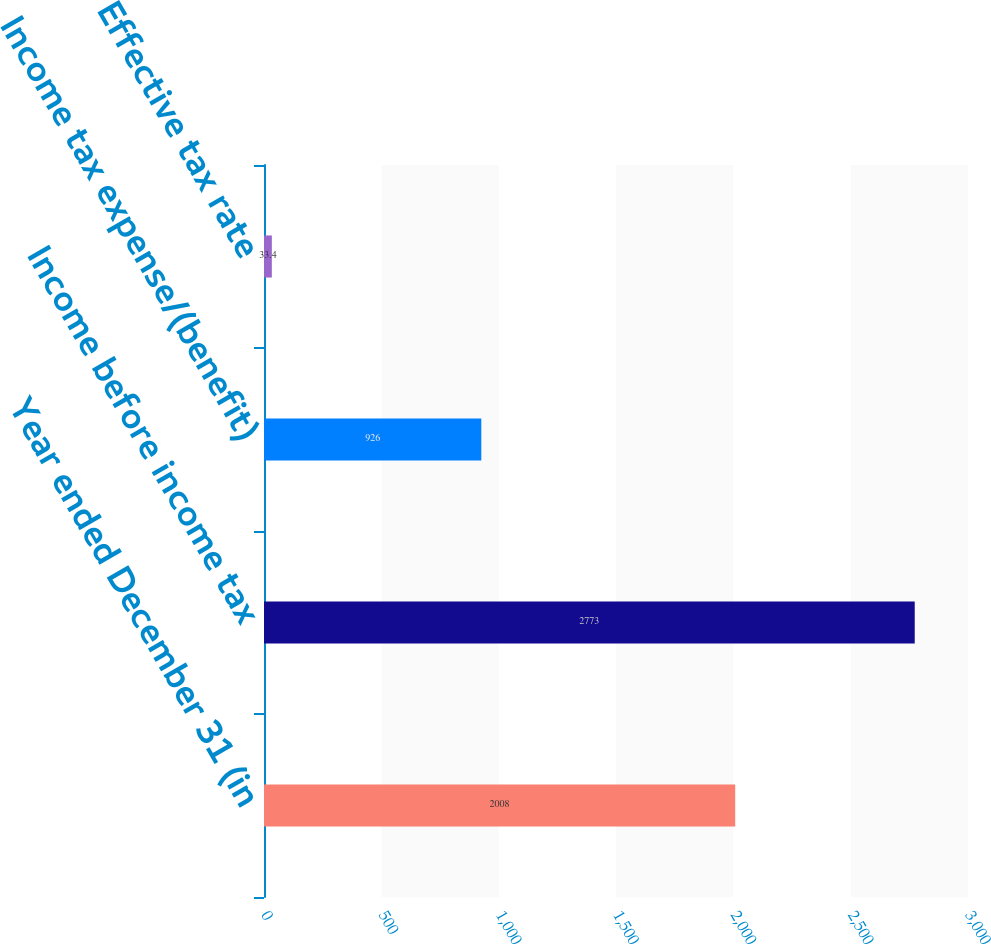<chart> <loc_0><loc_0><loc_500><loc_500><bar_chart><fcel>Year ended December 31 (in<fcel>Income before income tax<fcel>Income tax expense/(benefit)<fcel>Effective tax rate<nl><fcel>2008<fcel>2773<fcel>926<fcel>33.4<nl></chart> 